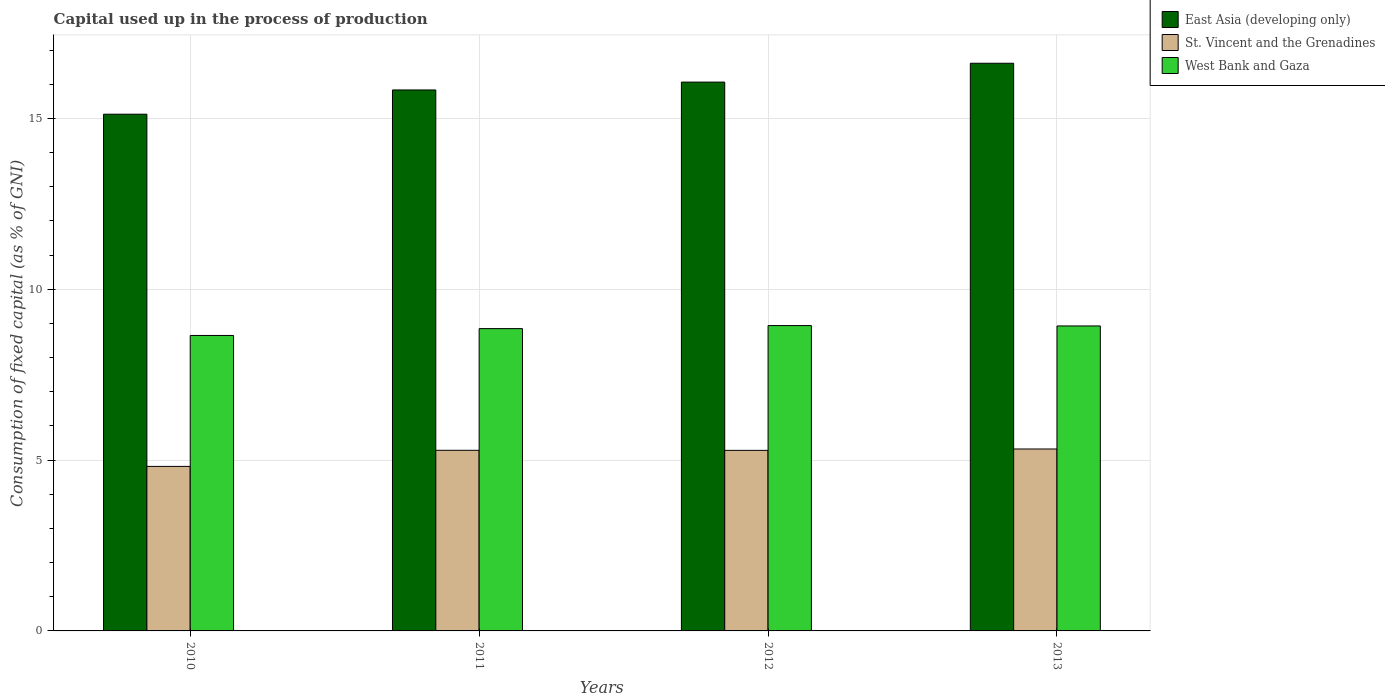How many different coloured bars are there?
Offer a terse response. 3. In how many cases, is the number of bars for a given year not equal to the number of legend labels?
Your answer should be very brief. 0. What is the capital used up in the process of production in St. Vincent and the Grenadines in 2011?
Ensure brevity in your answer.  5.29. Across all years, what is the maximum capital used up in the process of production in St. Vincent and the Grenadines?
Your response must be concise. 5.32. Across all years, what is the minimum capital used up in the process of production in West Bank and Gaza?
Make the answer very short. 8.65. In which year was the capital used up in the process of production in East Asia (developing only) maximum?
Offer a terse response. 2013. In which year was the capital used up in the process of production in West Bank and Gaza minimum?
Ensure brevity in your answer.  2010. What is the total capital used up in the process of production in St. Vincent and the Grenadines in the graph?
Provide a short and direct response. 20.71. What is the difference between the capital used up in the process of production in St. Vincent and the Grenadines in 2010 and that in 2013?
Provide a succinct answer. -0.51. What is the difference between the capital used up in the process of production in West Bank and Gaza in 2011 and the capital used up in the process of production in St. Vincent and the Grenadines in 2013?
Make the answer very short. 3.52. What is the average capital used up in the process of production in West Bank and Gaza per year?
Your answer should be compact. 8.84. In the year 2012, what is the difference between the capital used up in the process of production in West Bank and Gaza and capital used up in the process of production in East Asia (developing only)?
Your answer should be very brief. -7.13. In how many years, is the capital used up in the process of production in East Asia (developing only) greater than 9 %?
Give a very brief answer. 4. What is the ratio of the capital used up in the process of production in West Bank and Gaza in 2010 to that in 2011?
Provide a succinct answer. 0.98. Is the capital used up in the process of production in St. Vincent and the Grenadines in 2011 less than that in 2012?
Provide a succinct answer. No. Is the difference between the capital used up in the process of production in West Bank and Gaza in 2012 and 2013 greater than the difference between the capital used up in the process of production in East Asia (developing only) in 2012 and 2013?
Give a very brief answer. Yes. What is the difference between the highest and the second highest capital used up in the process of production in West Bank and Gaza?
Keep it short and to the point. 0.01. What is the difference between the highest and the lowest capital used up in the process of production in St. Vincent and the Grenadines?
Provide a succinct answer. 0.51. What does the 2nd bar from the left in 2011 represents?
Your answer should be very brief. St. Vincent and the Grenadines. What does the 1st bar from the right in 2012 represents?
Your response must be concise. West Bank and Gaza. Is it the case that in every year, the sum of the capital used up in the process of production in East Asia (developing only) and capital used up in the process of production in St. Vincent and the Grenadines is greater than the capital used up in the process of production in West Bank and Gaza?
Keep it short and to the point. Yes. How many years are there in the graph?
Provide a succinct answer. 4. Does the graph contain any zero values?
Offer a terse response. No. Does the graph contain grids?
Give a very brief answer. Yes. Where does the legend appear in the graph?
Offer a very short reply. Top right. How many legend labels are there?
Your response must be concise. 3. What is the title of the graph?
Provide a short and direct response. Capital used up in the process of production. What is the label or title of the Y-axis?
Provide a succinct answer. Consumption of fixed capital (as % of GNI). What is the Consumption of fixed capital (as % of GNI) of East Asia (developing only) in 2010?
Make the answer very short. 15.12. What is the Consumption of fixed capital (as % of GNI) of St. Vincent and the Grenadines in 2010?
Offer a terse response. 4.82. What is the Consumption of fixed capital (as % of GNI) of West Bank and Gaza in 2010?
Provide a short and direct response. 8.65. What is the Consumption of fixed capital (as % of GNI) of East Asia (developing only) in 2011?
Ensure brevity in your answer.  15.83. What is the Consumption of fixed capital (as % of GNI) of St. Vincent and the Grenadines in 2011?
Offer a terse response. 5.29. What is the Consumption of fixed capital (as % of GNI) of West Bank and Gaza in 2011?
Provide a succinct answer. 8.85. What is the Consumption of fixed capital (as % of GNI) of East Asia (developing only) in 2012?
Your response must be concise. 16.06. What is the Consumption of fixed capital (as % of GNI) of St. Vincent and the Grenadines in 2012?
Your answer should be compact. 5.28. What is the Consumption of fixed capital (as % of GNI) in West Bank and Gaza in 2012?
Your answer should be compact. 8.94. What is the Consumption of fixed capital (as % of GNI) in East Asia (developing only) in 2013?
Give a very brief answer. 16.61. What is the Consumption of fixed capital (as % of GNI) in St. Vincent and the Grenadines in 2013?
Your answer should be compact. 5.32. What is the Consumption of fixed capital (as % of GNI) in West Bank and Gaza in 2013?
Your answer should be very brief. 8.93. Across all years, what is the maximum Consumption of fixed capital (as % of GNI) in East Asia (developing only)?
Give a very brief answer. 16.61. Across all years, what is the maximum Consumption of fixed capital (as % of GNI) in St. Vincent and the Grenadines?
Your response must be concise. 5.32. Across all years, what is the maximum Consumption of fixed capital (as % of GNI) in West Bank and Gaza?
Your answer should be very brief. 8.94. Across all years, what is the minimum Consumption of fixed capital (as % of GNI) of East Asia (developing only)?
Make the answer very short. 15.12. Across all years, what is the minimum Consumption of fixed capital (as % of GNI) in St. Vincent and the Grenadines?
Offer a very short reply. 4.82. Across all years, what is the minimum Consumption of fixed capital (as % of GNI) in West Bank and Gaza?
Offer a very short reply. 8.65. What is the total Consumption of fixed capital (as % of GNI) in East Asia (developing only) in the graph?
Give a very brief answer. 63.64. What is the total Consumption of fixed capital (as % of GNI) of St. Vincent and the Grenadines in the graph?
Your response must be concise. 20.71. What is the total Consumption of fixed capital (as % of GNI) in West Bank and Gaza in the graph?
Provide a short and direct response. 35.36. What is the difference between the Consumption of fixed capital (as % of GNI) of East Asia (developing only) in 2010 and that in 2011?
Offer a terse response. -0.71. What is the difference between the Consumption of fixed capital (as % of GNI) of St. Vincent and the Grenadines in 2010 and that in 2011?
Your answer should be very brief. -0.47. What is the difference between the Consumption of fixed capital (as % of GNI) in West Bank and Gaza in 2010 and that in 2011?
Ensure brevity in your answer.  -0.2. What is the difference between the Consumption of fixed capital (as % of GNI) of East Asia (developing only) in 2010 and that in 2012?
Make the answer very short. -0.94. What is the difference between the Consumption of fixed capital (as % of GNI) in St. Vincent and the Grenadines in 2010 and that in 2012?
Your answer should be compact. -0.47. What is the difference between the Consumption of fixed capital (as % of GNI) in West Bank and Gaza in 2010 and that in 2012?
Make the answer very short. -0.29. What is the difference between the Consumption of fixed capital (as % of GNI) in East Asia (developing only) in 2010 and that in 2013?
Your response must be concise. -1.49. What is the difference between the Consumption of fixed capital (as % of GNI) of St. Vincent and the Grenadines in 2010 and that in 2013?
Give a very brief answer. -0.51. What is the difference between the Consumption of fixed capital (as % of GNI) of West Bank and Gaza in 2010 and that in 2013?
Offer a terse response. -0.28. What is the difference between the Consumption of fixed capital (as % of GNI) in East Asia (developing only) in 2011 and that in 2012?
Offer a terse response. -0.23. What is the difference between the Consumption of fixed capital (as % of GNI) of St. Vincent and the Grenadines in 2011 and that in 2012?
Offer a very short reply. 0. What is the difference between the Consumption of fixed capital (as % of GNI) in West Bank and Gaza in 2011 and that in 2012?
Your answer should be compact. -0.09. What is the difference between the Consumption of fixed capital (as % of GNI) of East Asia (developing only) in 2011 and that in 2013?
Provide a short and direct response. -0.78. What is the difference between the Consumption of fixed capital (as % of GNI) in St. Vincent and the Grenadines in 2011 and that in 2013?
Keep it short and to the point. -0.04. What is the difference between the Consumption of fixed capital (as % of GNI) in West Bank and Gaza in 2011 and that in 2013?
Give a very brief answer. -0.08. What is the difference between the Consumption of fixed capital (as % of GNI) of East Asia (developing only) in 2012 and that in 2013?
Ensure brevity in your answer.  -0.55. What is the difference between the Consumption of fixed capital (as % of GNI) in St. Vincent and the Grenadines in 2012 and that in 2013?
Make the answer very short. -0.04. What is the difference between the Consumption of fixed capital (as % of GNI) of West Bank and Gaza in 2012 and that in 2013?
Your response must be concise. 0.01. What is the difference between the Consumption of fixed capital (as % of GNI) of East Asia (developing only) in 2010 and the Consumption of fixed capital (as % of GNI) of St. Vincent and the Grenadines in 2011?
Make the answer very short. 9.84. What is the difference between the Consumption of fixed capital (as % of GNI) of East Asia (developing only) in 2010 and the Consumption of fixed capital (as % of GNI) of West Bank and Gaza in 2011?
Your response must be concise. 6.28. What is the difference between the Consumption of fixed capital (as % of GNI) in St. Vincent and the Grenadines in 2010 and the Consumption of fixed capital (as % of GNI) in West Bank and Gaza in 2011?
Your answer should be very brief. -4.03. What is the difference between the Consumption of fixed capital (as % of GNI) of East Asia (developing only) in 2010 and the Consumption of fixed capital (as % of GNI) of St. Vincent and the Grenadines in 2012?
Your answer should be very brief. 9.84. What is the difference between the Consumption of fixed capital (as % of GNI) in East Asia (developing only) in 2010 and the Consumption of fixed capital (as % of GNI) in West Bank and Gaza in 2012?
Make the answer very short. 6.19. What is the difference between the Consumption of fixed capital (as % of GNI) of St. Vincent and the Grenadines in 2010 and the Consumption of fixed capital (as % of GNI) of West Bank and Gaza in 2012?
Provide a short and direct response. -4.12. What is the difference between the Consumption of fixed capital (as % of GNI) of East Asia (developing only) in 2010 and the Consumption of fixed capital (as % of GNI) of St. Vincent and the Grenadines in 2013?
Ensure brevity in your answer.  9.8. What is the difference between the Consumption of fixed capital (as % of GNI) in East Asia (developing only) in 2010 and the Consumption of fixed capital (as % of GNI) in West Bank and Gaza in 2013?
Offer a very short reply. 6.2. What is the difference between the Consumption of fixed capital (as % of GNI) in St. Vincent and the Grenadines in 2010 and the Consumption of fixed capital (as % of GNI) in West Bank and Gaza in 2013?
Your answer should be very brief. -4.11. What is the difference between the Consumption of fixed capital (as % of GNI) in East Asia (developing only) in 2011 and the Consumption of fixed capital (as % of GNI) in St. Vincent and the Grenadines in 2012?
Keep it short and to the point. 10.55. What is the difference between the Consumption of fixed capital (as % of GNI) in East Asia (developing only) in 2011 and the Consumption of fixed capital (as % of GNI) in West Bank and Gaza in 2012?
Provide a short and direct response. 6.9. What is the difference between the Consumption of fixed capital (as % of GNI) in St. Vincent and the Grenadines in 2011 and the Consumption of fixed capital (as % of GNI) in West Bank and Gaza in 2012?
Make the answer very short. -3.65. What is the difference between the Consumption of fixed capital (as % of GNI) of East Asia (developing only) in 2011 and the Consumption of fixed capital (as % of GNI) of St. Vincent and the Grenadines in 2013?
Offer a terse response. 10.51. What is the difference between the Consumption of fixed capital (as % of GNI) in East Asia (developing only) in 2011 and the Consumption of fixed capital (as % of GNI) in West Bank and Gaza in 2013?
Your response must be concise. 6.91. What is the difference between the Consumption of fixed capital (as % of GNI) of St. Vincent and the Grenadines in 2011 and the Consumption of fixed capital (as % of GNI) of West Bank and Gaza in 2013?
Your answer should be compact. -3.64. What is the difference between the Consumption of fixed capital (as % of GNI) of East Asia (developing only) in 2012 and the Consumption of fixed capital (as % of GNI) of St. Vincent and the Grenadines in 2013?
Make the answer very short. 10.74. What is the difference between the Consumption of fixed capital (as % of GNI) in East Asia (developing only) in 2012 and the Consumption of fixed capital (as % of GNI) in West Bank and Gaza in 2013?
Make the answer very short. 7.14. What is the difference between the Consumption of fixed capital (as % of GNI) in St. Vincent and the Grenadines in 2012 and the Consumption of fixed capital (as % of GNI) in West Bank and Gaza in 2013?
Offer a very short reply. -3.64. What is the average Consumption of fixed capital (as % of GNI) in East Asia (developing only) per year?
Make the answer very short. 15.91. What is the average Consumption of fixed capital (as % of GNI) of St. Vincent and the Grenadines per year?
Your answer should be very brief. 5.18. What is the average Consumption of fixed capital (as % of GNI) of West Bank and Gaza per year?
Your response must be concise. 8.84. In the year 2010, what is the difference between the Consumption of fixed capital (as % of GNI) in East Asia (developing only) and Consumption of fixed capital (as % of GNI) in St. Vincent and the Grenadines?
Provide a succinct answer. 10.31. In the year 2010, what is the difference between the Consumption of fixed capital (as % of GNI) of East Asia (developing only) and Consumption of fixed capital (as % of GNI) of West Bank and Gaza?
Offer a very short reply. 6.48. In the year 2010, what is the difference between the Consumption of fixed capital (as % of GNI) in St. Vincent and the Grenadines and Consumption of fixed capital (as % of GNI) in West Bank and Gaza?
Your response must be concise. -3.83. In the year 2011, what is the difference between the Consumption of fixed capital (as % of GNI) of East Asia (developing only) and Consumption of fixed capital (as % of GNI) of St. Vincent and the Grenadines?
Provide a short and direct response. 10.55. In the year 2011, what is the difference between the Consumption of fixed capital (as % of GNI) in East Asia (developing only) and Consumption of fixed capital (as % of GNI) in West Bank and Gaza?
Offer a terse response. 6.99. In the year 2011, what is the difference between the Consumption of fixed capital (as % of GNI) in St. Vincent and the Grenadines and Consumption of fixed capital (as % of GNI) in West Bank and Gaza?
Your answer should be compact. -3.56. In the year 2012, what is the difference between the Consumption of fixed capital (as % of GNI) in East Asia (developing only) and Consumption of fixed capital (as % of GNI) in St. Vincent and the Grenadines?
Your answer should be compact. 10.78. In the year 2012, what is the difference between the Consumption of fixed capital (as % of GNI) in East Asia (developing only) and Consumption of fixed capital (as % of GNI) in West Bank and Gaza?
Keep it short and to the point. 7.13. In the year 2012, what is the difference between the Consumption of fixed capital (as % of GNI) in St. Vincent and the Grenadines and Consumption of fixed capital (as % of GNI) in West Bank and Gaza?
Offer a very short reply. -3.65. In the year 2013, what is the difference between the Consumption of fixed capital (as % of GNI) in East Asia (developing only) and Consumption of fixed capital (as % of GNI) in St. Vincent and the Grenadines?
Keep it short and to the point. 11.29. In the year 2013, what is the difference between the Consumption of fixed capital (as % of GNI) of East Asia (developing only) and Consumption of fixed capital (as % of GNI) of West Bank and Gaza?
Give a very brief answer. 7.69. In the year 2013, what is the difference between the Consumption of fixed capital (as % of GNI) of St. Vincent and the Grenadines and Consumption of fixed capital (as % of GNI) of West Bank and Gaza?
Make the answer very short. -3.6. What is the ratio of the Consumption of fixed capital (as % of GNI) in East Asia (developing only) in 2010 to that in 2011?
Your answer should be very brief. 0.96. What is the ratio of the Consumption of fixed capital (as % of GNI) of St. Vincent and the Grenadines in 2010 to that in 2011?
Provide a succinct answer. 0.91. What is the ratio of the Consumption of fixed capital (as % of GNI) of West Bank and Gaza in 2010 to that in 2011?
Give a very brief answer. 0.98. What is the ratio of the Consumption of fixed capital (as % of GNI) in East Asia (developing only) in 2010 to that in 2012?
Give a very brief answer. 0.94. What is the ratio of the Consumption of fixed capital (as % of GNI) in St. Vincent and the Grenadines in 2010 to that in 2012?
Your answer should be compact. 0.91. What is the ratio of the Consumption of fixed capital (as % of GNI) of West Bank and Gaza in 2010 to that in 2012?
Your answer should be very brief. 0.97. What is the ratio of the Consumption of fixed capital (as % of GNI) of East Asia (developing only) in 2010 to that in 2013?
Your answer should be very brief. 0.91. What is the ratio of the Consumption of fixed capital (as % of GNI) in St. Vincent and the Grenadines in 2010 to that in 2013?
Provide a short and direct response. 0.9. What is the ratio of the Consumption of fixed capital (as % of GNI) of West Bank and Gaza in 2010 to that in 2013?
Your answer should be very brief. 0.97. What is the ratio of the Consumption of fixed capital (as % of GNI) in East Asia (developing only) in 2011 to that in 2012?
Provide a succinct answer. 0.99. What is the ratio of the Consumption of fixed capital (as % of GNI) in West Bank and Gaza in 2011 to that in 2012?
Offer a very short reply. 0.99. What is the ratio of the Consumption of fixed capital (as % of GNI) in East Asia (developing only) in 2011 to that in 2013?
Your answer should be very brief. 0.95. What is the ratio of the Consumption of fixed capital (as % of GNI) of East Asia (developing only) in 2012 to that in 2013?
Your answer should be very brief. 0.97. What is the ratio of the Consumption of fixed capital (as % of GNI) of St. Vincent and the Grenadines in 2012 to that in 2013?
Offer a terse response. 0.99. What is the difference between the highest and the second highest Consumption of fixed capital (as % of GNI) in East Asia (developing only)?
Provide a short and direct response. 0.55. What is the difference between the highest and the second highest Consumption of fixed capital (as % of GNI) in St. Vincent and the Grenadines?
Give a very brief answer. 0.04. What is the difference between the highest and the second highest Consumption of fixed capital (as % of GNI) of West Bank and Gaza?
Your answer should be compact. 0.01. What is the difference between the highest and the lowest Consumption of fixed capital (as % of GNI) in East Asia (developing only)?
Make the answer very short. 1.49. What is the difference between the highest and the lowest Consumption of fixed capital (as % of GNI) in St. Vincent and the Grenadines?
Offer a terse response. 0.51. What is the difference between the highest and the lowest Consumption of fixed capital (as % of GNI) of West Bank and Gaza?
Provide a succinct answer. 0.29. 